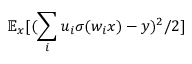Convert formula to latex. <formula><loc_0><loc_0><loc_500><loc_500>\mathbb { E } _ { x } [ ( \sum _ { i } u _ { i } \sigma ( w _ { i } x ) - y ) ^ { 2 } / 2 ]</formula> 